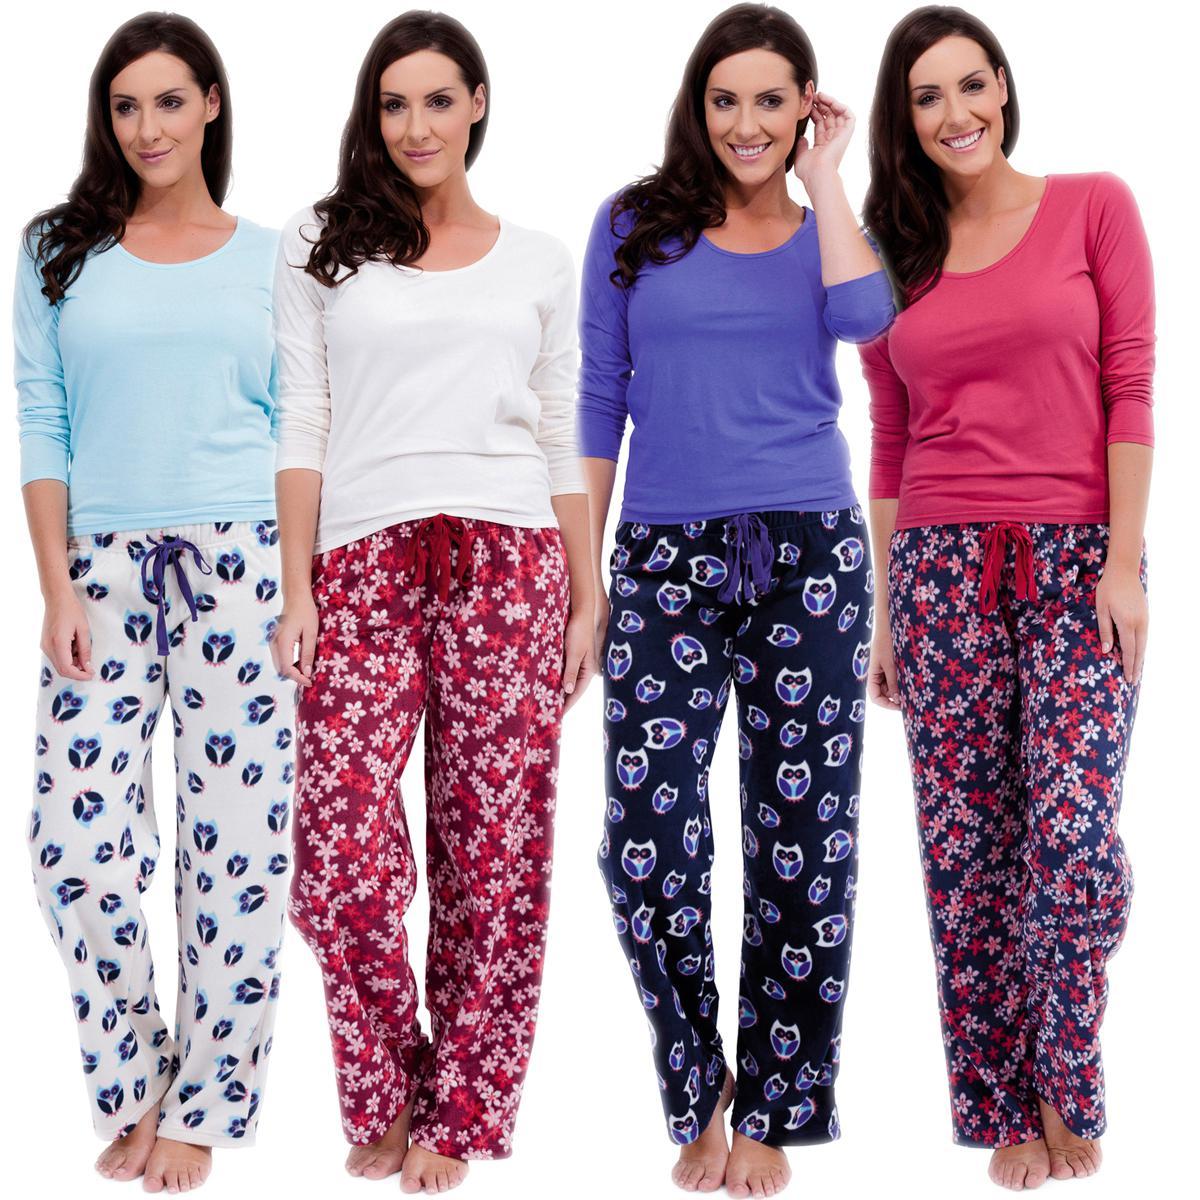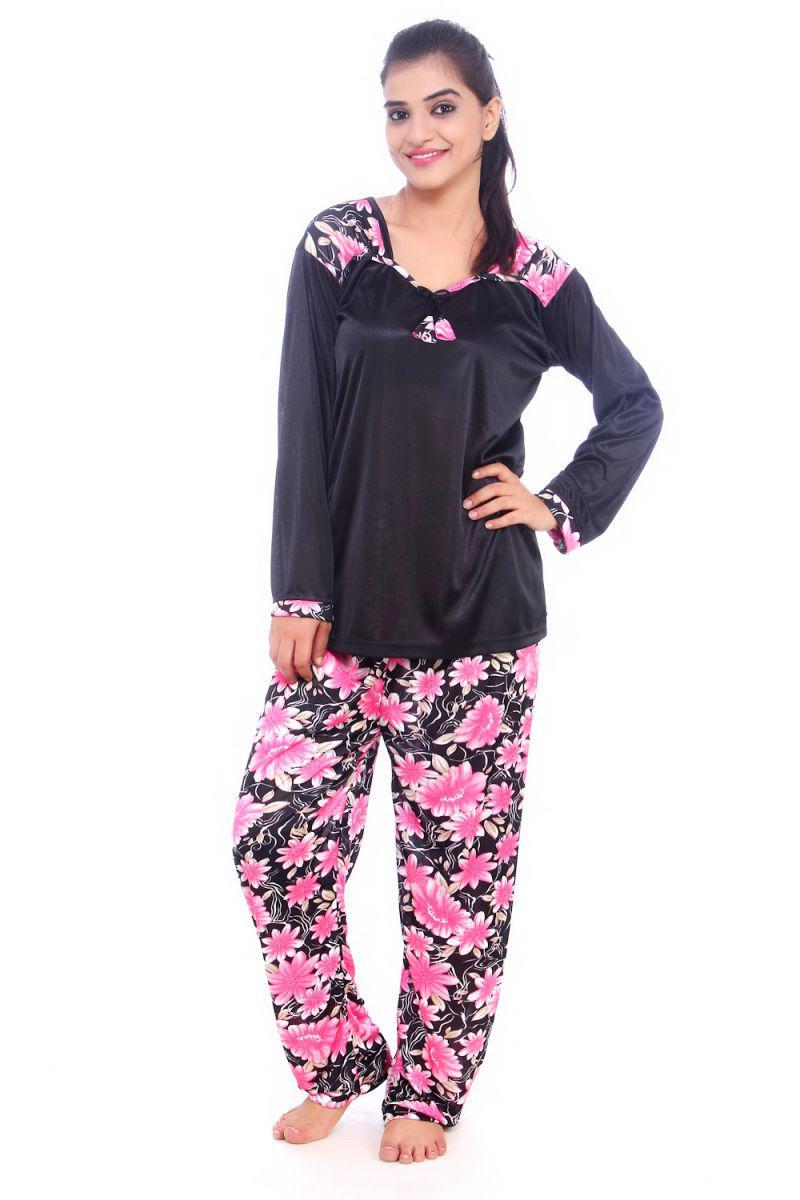The first image is the image on the left, the second image is the image on the right. For the images shown, is this caption "There are at least four women in the image on the left." true? Answer yes or no. Yes. 